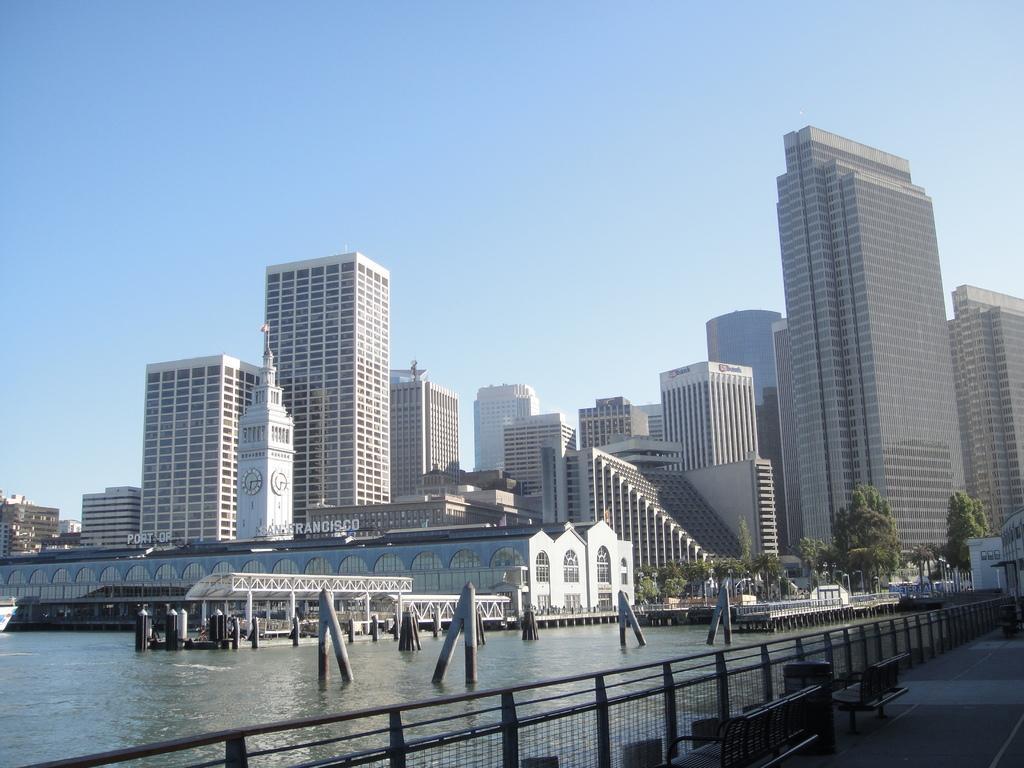Can you describe this image briefly? In the picture there is a water surface and behind the water surface there are many buildings and on the right side there is a path and there are few benches on that path, there are many trees in front of the buildings. 